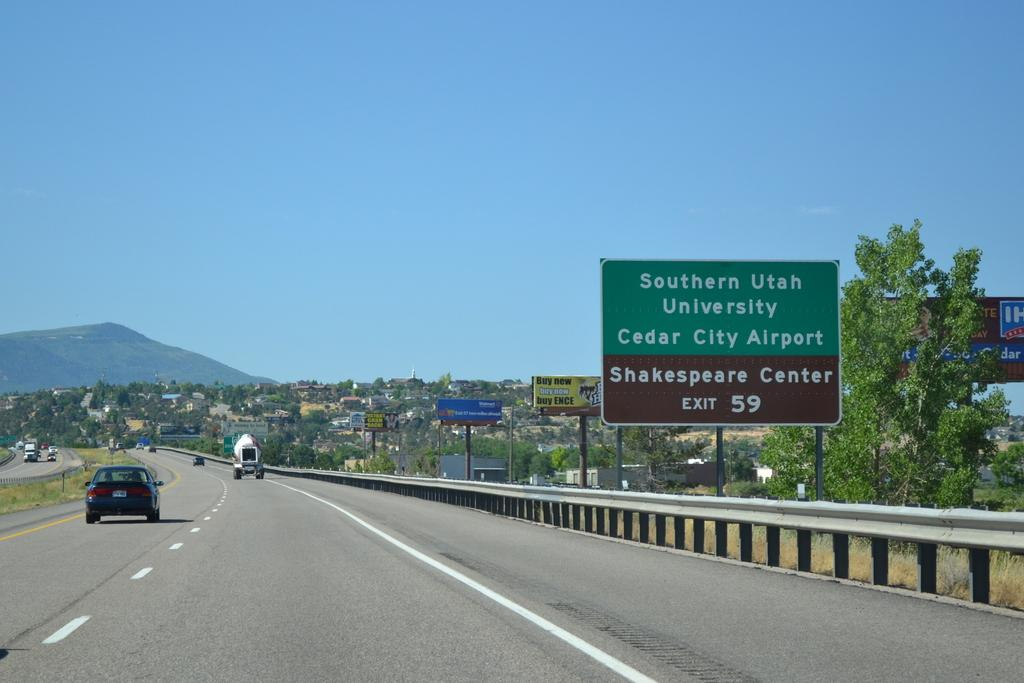<image>
Summarize the visual content of the image. Cars driving through a highway with a green road sign displaying an exit for Southern Utah University. 